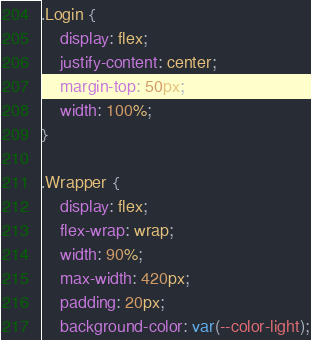<code> <loc_0><loc_0><loc_500><loc_500><_CSS_>.Login {
    display: flex;
    justify-content: center;
    margin-top: 50px;
    width: 100%;
}

.Wrapper {
    display: flex;
    flex-wrap: wrap;
    width: 90%;
    max-width: 420px;
    padding: 20px;
    background-color: var(--color-light);</code> 